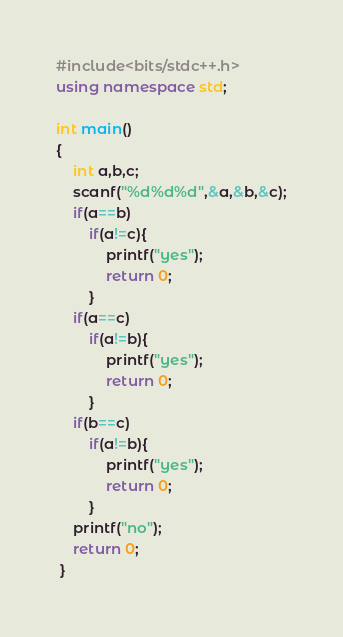<code> <loc_0><loc_0><loc_500><loc_500><_C++_>#include<bits/stdc++.h>
using namespace std;

int main()
{
	int a,b,c;
	scanf("%d%d%d",&a,&b,&c);
	if(a==b)
		if(a!=c){
			printf("yes");
			return 0;
		}
	if(a==c)
		if(a!=b){
			printf("yes");
			return 0;
		}
	if(b==c)
		if(a!=b){
			printf("yes");
			return 0;
		}
	printf("no");
	return 0;
 } </code> 